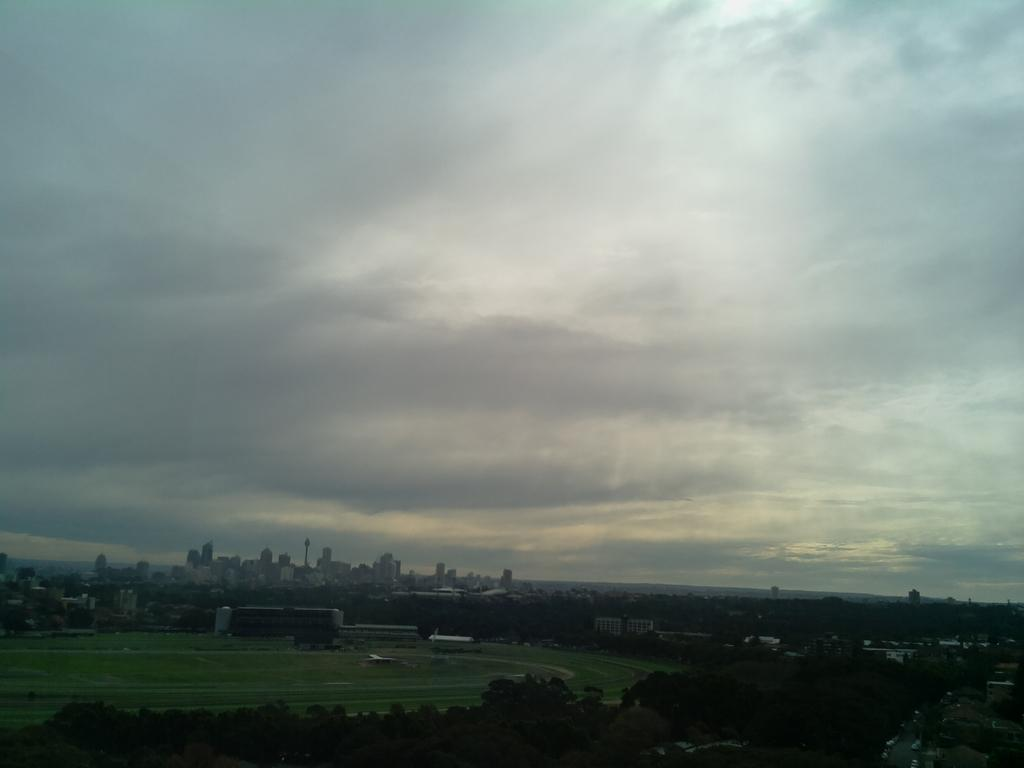What is located in the middle of the image? There is a ground in the middle of the image. What can be seen in the background of the image? There are many trees at the back of the image and the sky in the background. What type of structures are present in the image? There are buildings in the image. Can you see any bikes or veils in the image? There are no bikes or veils present in the image. Is there a war happening in the image? There is no indication of a war in the image; it features a ground, trees, sky, and buildings. 